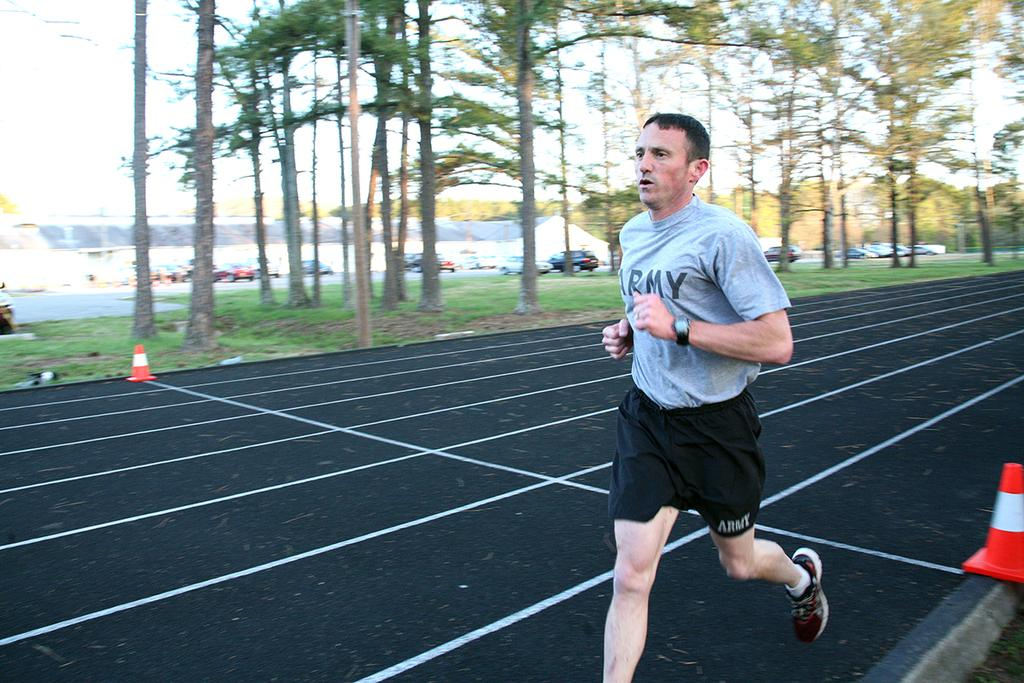Provide a one-sentence caption for the provided image. A man wearing a grey Army shirt is running on a track. 